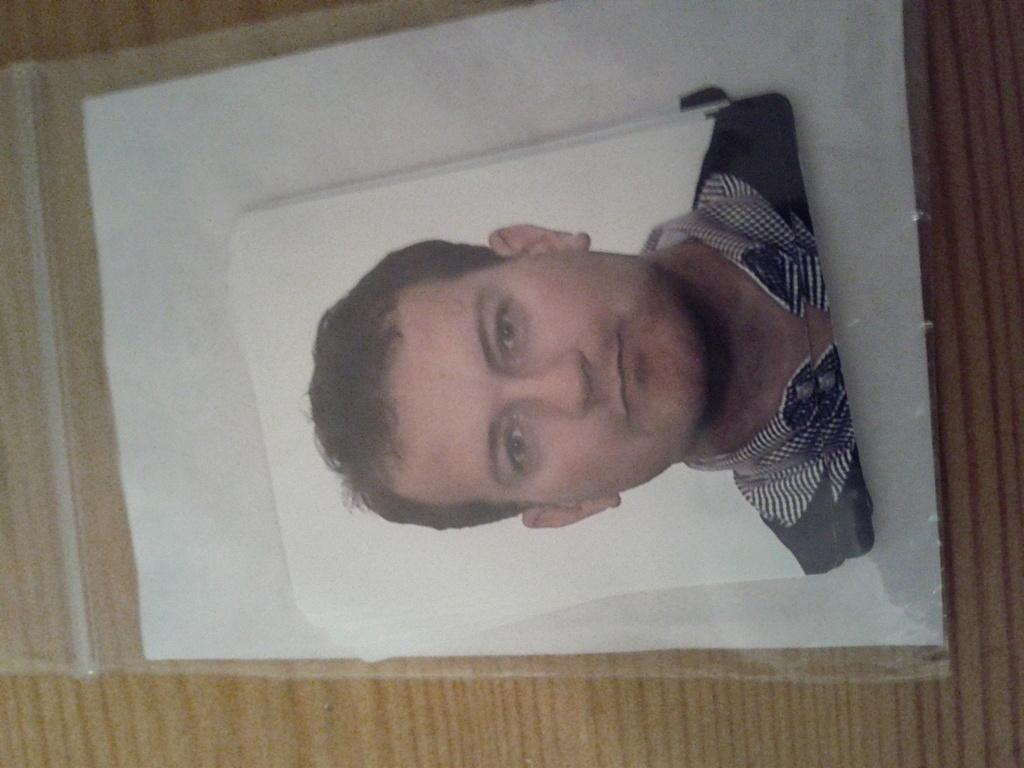What is the main subject of the image? The main subject of the image is a photo of a person. How is the photo of the person presented in the image? The photo is placed in a cover. What color is the lip of the person in the image? There is no lip visible in the image, as it only shows a photo of a person placed in a cover. 